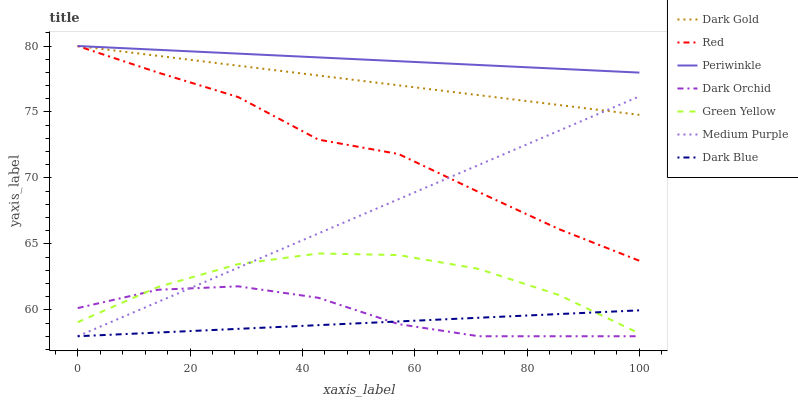Does Dark Blue have the minimum area under the curve?
Answer yes or no. Yes. Does Periwinkle have the maximum area under the curve?
Answer yes or no. Yes. Does Dark Orchid have the minimum area under the curve?
Answer yes or no. No. Does Dark Orchid have the maximum area under the curve?
Answer yes or no. No. Is Dark Blue the smoothest?
Answer yes or no. Yes. Is Red the roughest?
Answer yes or no. Yes. Is Dark Orchid the smoothest?
Answer yes or no. No. Is Dark Orchid the roughest?
Answer yes or no. No. Does Periwinkle have the lowest value?
Answer yes or no. No. Does Red have the highest value?
Answer yes or no. Yes. Does Dark Orchid have the highest value?
Answer yes or no. No. Is Dark Orchid less than Dark Gold?
Answer yes or no. Yes. Is Periwinkle greater than Green Yellow?
Answer yes or no. Yes. Does Green Yellow intersect Dark Orchid?
Answer yes or no. Yes. Is Green Yellow less than Dark Orchid?
Answer yes or no. No. Is Green Yellow greater than Dark Orchid?
Answer yes or no. No. Does Dark Orchid intersect Dark Gold?
Answer yes or no. No. 